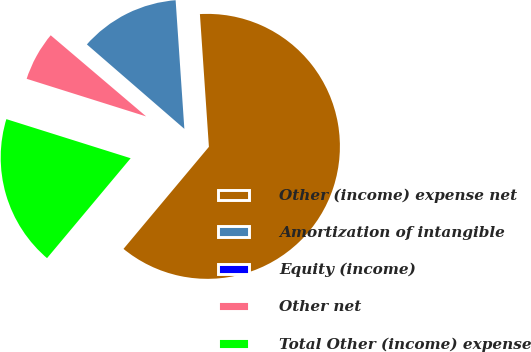<chart> <loc_0><loc_0><loc_500><loc_500><pie_chart><fcel>Other (income) expense net<fcel>Amortization of intangible<fcel>Equity (income)<fcel>Other net<fcel>Total Other (income) expense<nl><fcel>62.17%<fcel>12.56%<fcel>0.15%<fcel>6.36%<fcel>18.76%<nl></chart> 